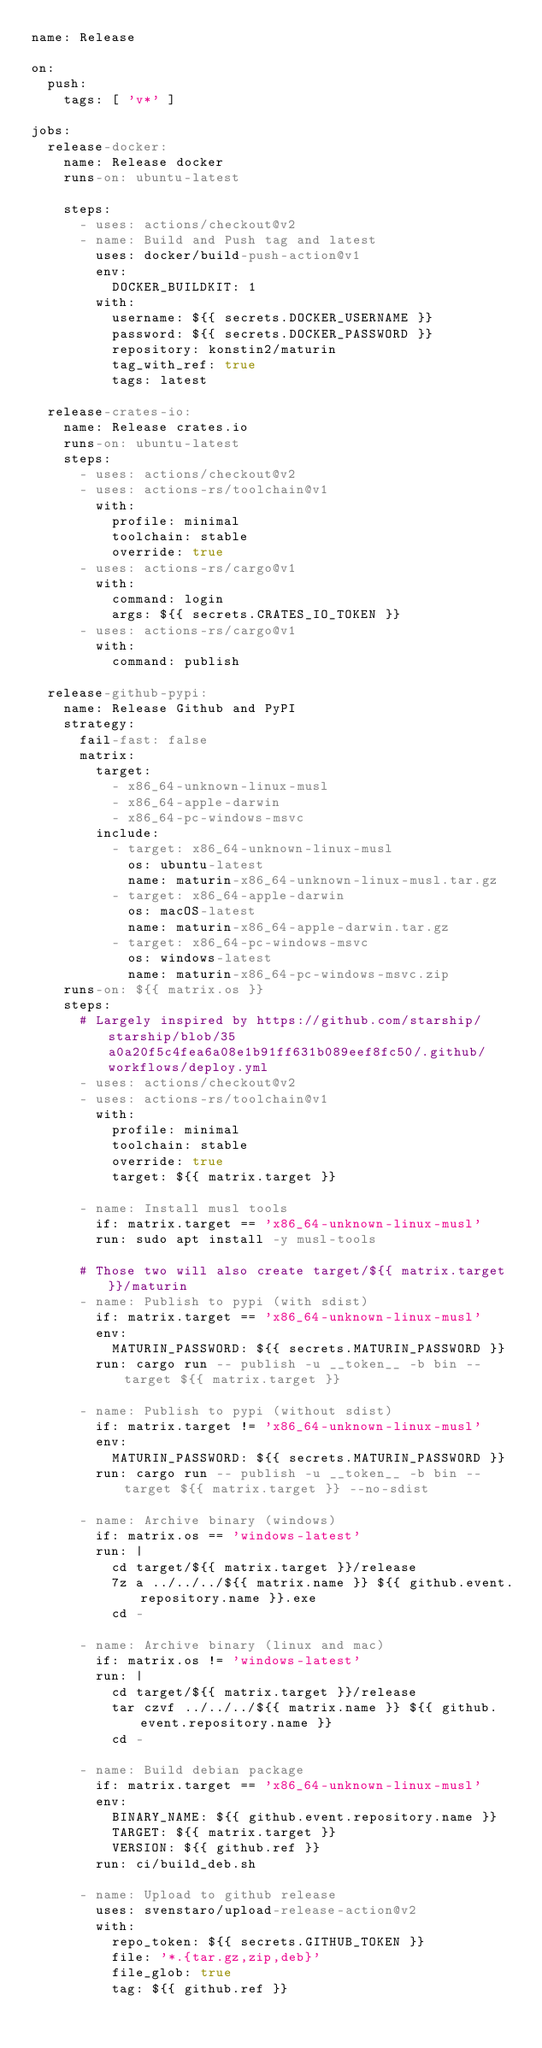<code> <loc_0><loc_0><loc_500><loc_500><_YAML_>name: Release

on:
  push:
    tags: [ 'v*' ]

jobs:
  release-docker:
    name: Release docker
    runs-on: ubuntu-latest

    steps:
      - uses: actions/checkout@v2
      - name: Build and Push tag and latest
        uses: docker/build-push-action@v1
        env:
          DOCKER_BUILDKIT: 1
        with:
          username: ${{ secrets.DOCKER_USERNAME }}
          password: ${{ secrets.DOCKER_PASSWORD }}
          repository: konstin2/maturin
          tag_with_ref: true
          tags: latest

  release-crates-io:
    name: Release crates.io
    runs-on: ubuntu-latest
    steps:
      - uses: actions/checkout@v2
      - uses: actions-rs/toolchain@v1
        with:
          profile: minimal
          toolchain: stable
          override: true
      - uses: actions-rs/cargo@v1
        with:
          command: login
          args: ${{ secrets.CRATES_IO_TOKEN }}
      - uses: actions-rs/cargo@v1
        with:
          command: publish

  release-github-pypi:
    name: Release Github and PyPI
    strategy:
      fail-fast: false
      matrix:
        target:
          - x86_64-unknown-linux-musl
          - x86_64-apple-darwin
          - x86_64-pc-windows-msvc
        include:
          - target: x86_64-unknown-linux-musl
            os: ubuntu-latest
            name: maturin-x86_64-unknown-linux-musl.tar.gz
          - target: x86_64-apple-darwin
            os: macOS-latest
            name: maturin-x86_64-apple-darwin.tar.gz
          - target: x86_64-pc-windows-msvc
            os: windows-latest
            name: maturin-x86_64-pc-windows-msvc.zip
    runs-on: ${{ matrix.os }}
    steps:
      # Largely inspired by https://github.com/starship/starship/blob/35a0a20f5c4fea6a08e1b91ff631b089eef8fc50/.github/workflows/deploy.yml
      - uses: actions/checkout@v2
      - uses: actions-rs/toolchain@v1
        with:
          profile: minimal
          toolchain: stable
          override: true
          target: ${{ matrix.target }}

      - name: Install musl tools
        if: matrix.target == 'x86_64-unknown-linux-musl'
        run: sudo apt install -y musl-tools

      # Those two will also create target/${{ matrix.target }}/maturin
      - name: Publish to pypi (with sdist)
        if: matrix.target == 'x86_64-unknown-linux-musl'
        env:
          MATURIN_PASSWORD: ${{ secrets.MATURIN_PASSWORD }}
        run: cargo run -- publish -u __token__ -b bin --target ${{ matrix.target }}

      - name: Publish to pypi (without sdist)
        if: matrix.target != 'x86_64-unknown-linux-musl'
        env:
          MATURIN_PASSWORD: ${{ secrets.MATURIN_PASSWORD }}
        run: cargo run -- publish -u __token__ -b bin --target ${{ matrix.target }} --no-sdist

      - name: Archive binary (windows)
        if: matrix.os == 'windows-latest'
        run: |
          cd target/${{ matrix.target }}/release
          7z a ../../../${{ matrix.name }} ${{ github.event.repository.name }}.exe
          cd -

      - name: Archive binary (linux and mac)
        if: matrix.os != 'windows-latest'
        run: |
          cd target/${{ matrix.target }}/release
          tar czvf ../../../${{ matrix.name }} ${{ github.event.repository.name }}
          cd -

      - name: Build debian package
        if: matrix.target == 'x86_64-unknown-linux-musl'
        env:
          BINARY_NAME: ${{ github.event.repository.name }}
          TARGET: ${{ matrix.target }}
          VERSION: ${{ github.ref }}
        run: ci/build_deb.sh

      - name: Upload to github release
        uses: svenstaro/upload-release-action@v2
        with:
          repo_token: ${{ secrets.GITHUB_TOKEN }}
          file: '*.{tar.gz,zip,deb}'
          file_glob: true
          tag: ${{ github.ref }}</code> 